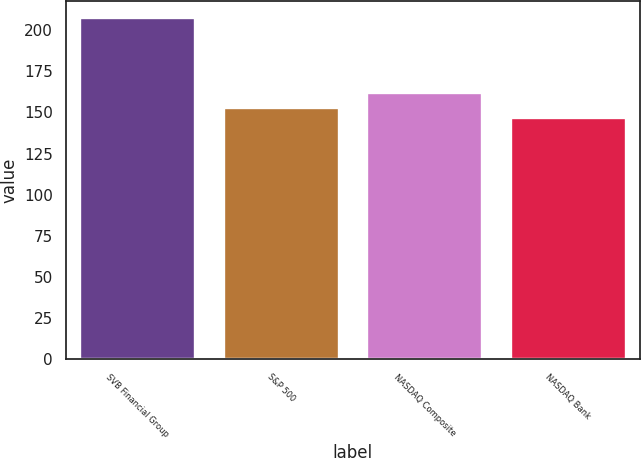<chart> <loc_0><loc_0><loc_500><loc_500><bar_chart><fcel>SVB Financial Group<fcel>S&P 500<fcel>NASDAQ Composite<fcel>NASDAQ Bank<nl><fcel>207.38<fcel>152.95<fcel>162.09<fcel>146.9<nl></chart> 